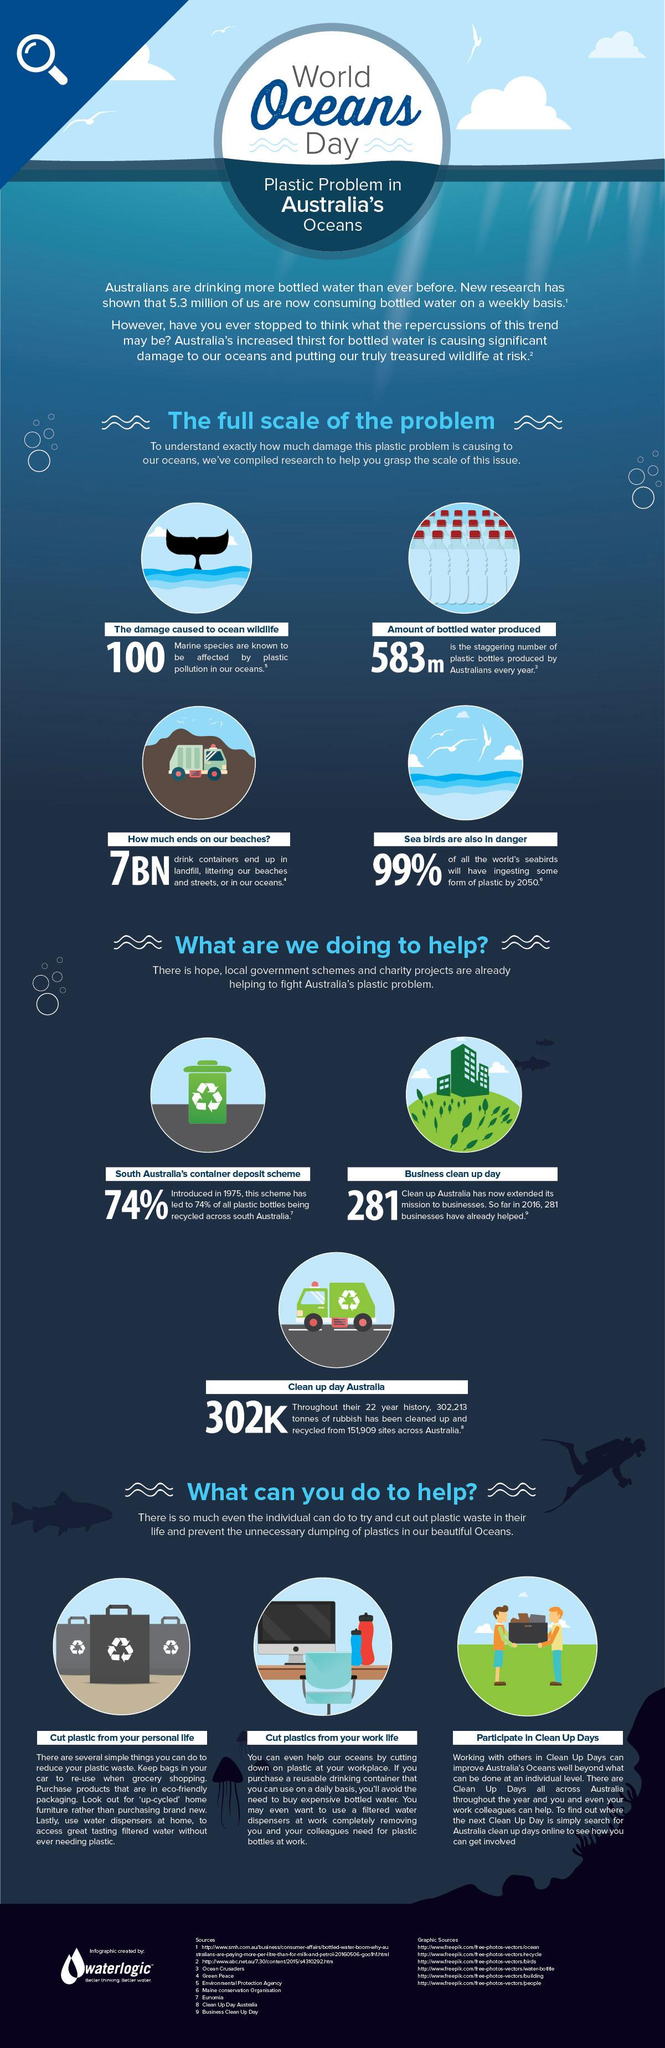List a handful of essential elements in this visual. In Australia, 74% of bottles are being recycled. According to estimates, over 583 species of oceanic animals are affected by plastic pollution. The exact number is difficult to determine, as scientists continue to study the impact of plastic on the world's oceans. However, it is clear that the number is significant, with many species facing the threat of extinction as a result of plastic pollution. 